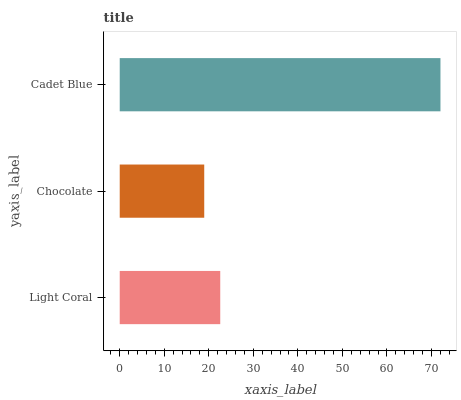Is Chocolate the minimum?
Answer yes or no. Yes. Is Cadet Blue the maximum?
Answer yes or no. Yes. Is Cadet Blue the minimum?
Answer yes or no. No. Is Chocolate the maximum?
Answer yes or no. No. Is Cadet Blue greater than Chocolate?
Answer yes or no. Yes. Is Chocolate less than Cadet Blue?
Answer yes or no. Yes. Is Chocolate greater than Cadet Blue?
Answer yes or no. No. Is Cadet Blue less than Chocolate?
Answer yes or no. No. Is Light Coral the high median?
Answer yes or no. Yes. Is Light Coral the low median?
Answer yes or no. Yes. Is Cadet Blue the high median?
Answer yes or no. No. Is Cadet Blue the low median?
Answer yes or no. No. 